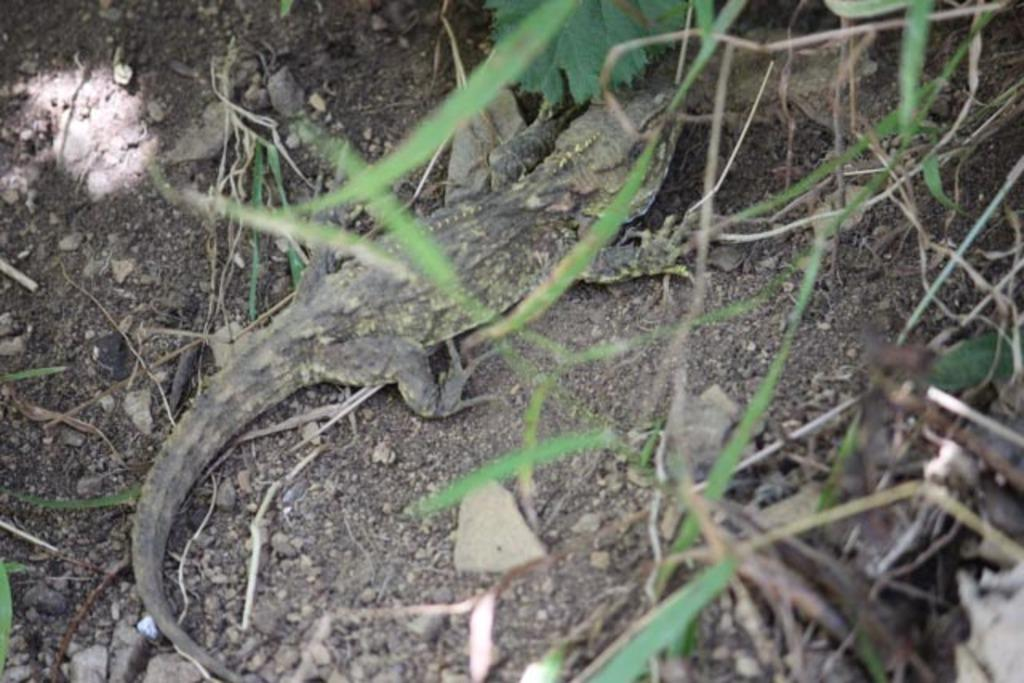What type of animal is in the center of the image? There is a reptile in the center of the image. Where is the reptile located? The reptile is on the ground. What can be seen in the background of the image? There is grass and stones in the background of the image. What type of work do the sisters of the reptile do in the image? There are no sisters or any indication of work in the image; it only features a reptile on the ground. 